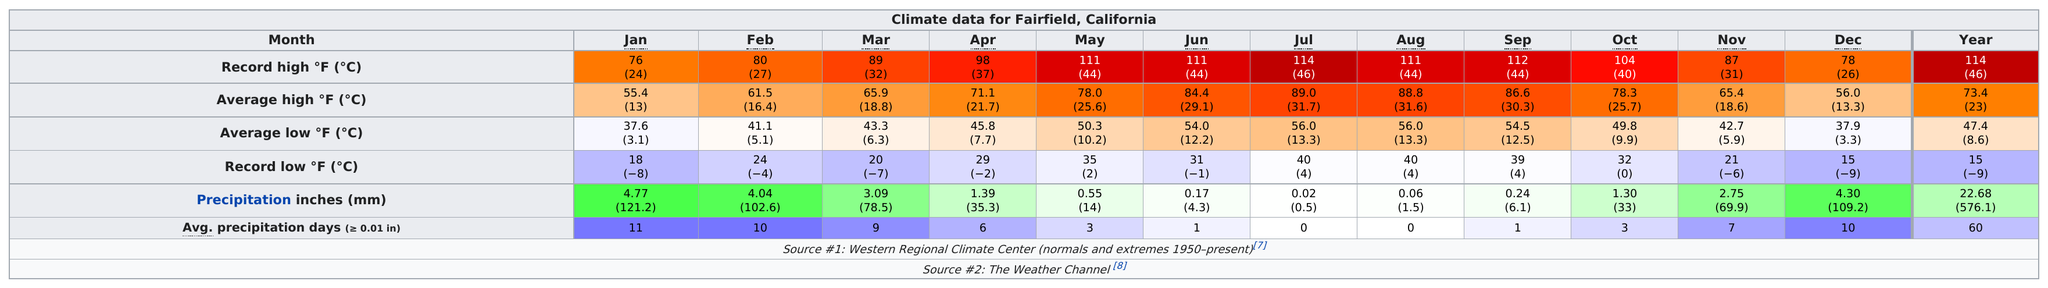Indicate a few pertinent items in this graphic. Six months have now passed since a record low temperature of below 25 degrees was reached. July was the month that had an average high of 89.0 degrees and an average low of 56.0 degrees. In the past, there were three months that set a record high of 111 degrees. 